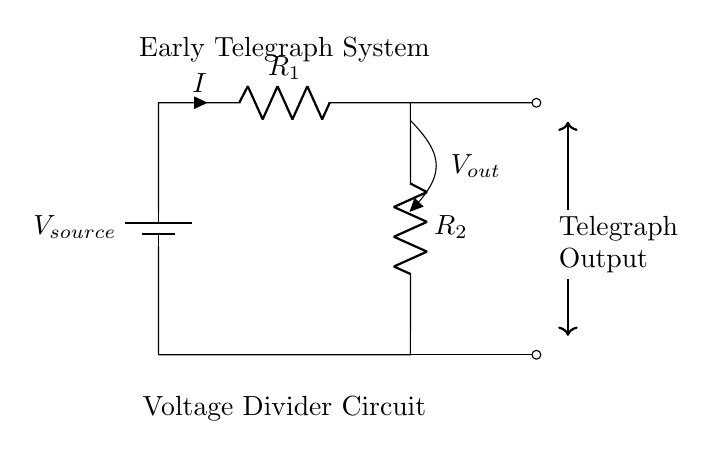What is the type of circuit depicted? The circuit is a voltage divider circuit. This can be determined by the presence of two resistors in series connected to a voltage source, creating divisions of voltage at different points in the circuit.
Answer: voltage divider circuit What is the output voltage labeled as? The output voltage in the diagram is labeled \( V_{out} \). This label is directly indicated in the circuit where the output is taken from at the top resistor.
Answer: Vout How many resistors are present in this circuit? There are two resistors in the circuit, identified as \( R_1 \) and \( R_2 \). This can be seen by counting the resistor symbols in the diagram.
Answer: 2 What is the role of the battery in this circuit? The battery provides the voltage source for the circuit. Its presence as the source component connects to the resistive elements allowing current to flow and voltage to be divided.
Answer: voltage source What does \( I \) represent in the circuit? \( I \) represents the current flowing through the circuit, typically passing through the first resistor \( R_1 \). This is indicated by the arrow pointing upwards from the resistor symbol, signifying the direction of current flow.
Answer: current What happens to the voltage as it passes through \( R_1 \)? As the voltage passes through \( R_1 \), it decreases from the source voltage, creating a voltage drop across \( R_1 \). This is a fundamental characteristic of a voltage divider, where the total voltage is divided between the series resistors based on their resistances.
Answer: decreases What is indicated at the right side of the circuit relating to telegraph systems? The right side of the circuit indicates an output to a telegraph system. It shows where the divided voltage can be used for signaling in early telegraph communications, demonstrating the practical application of the circuit.
Answer: Telegraph Output 